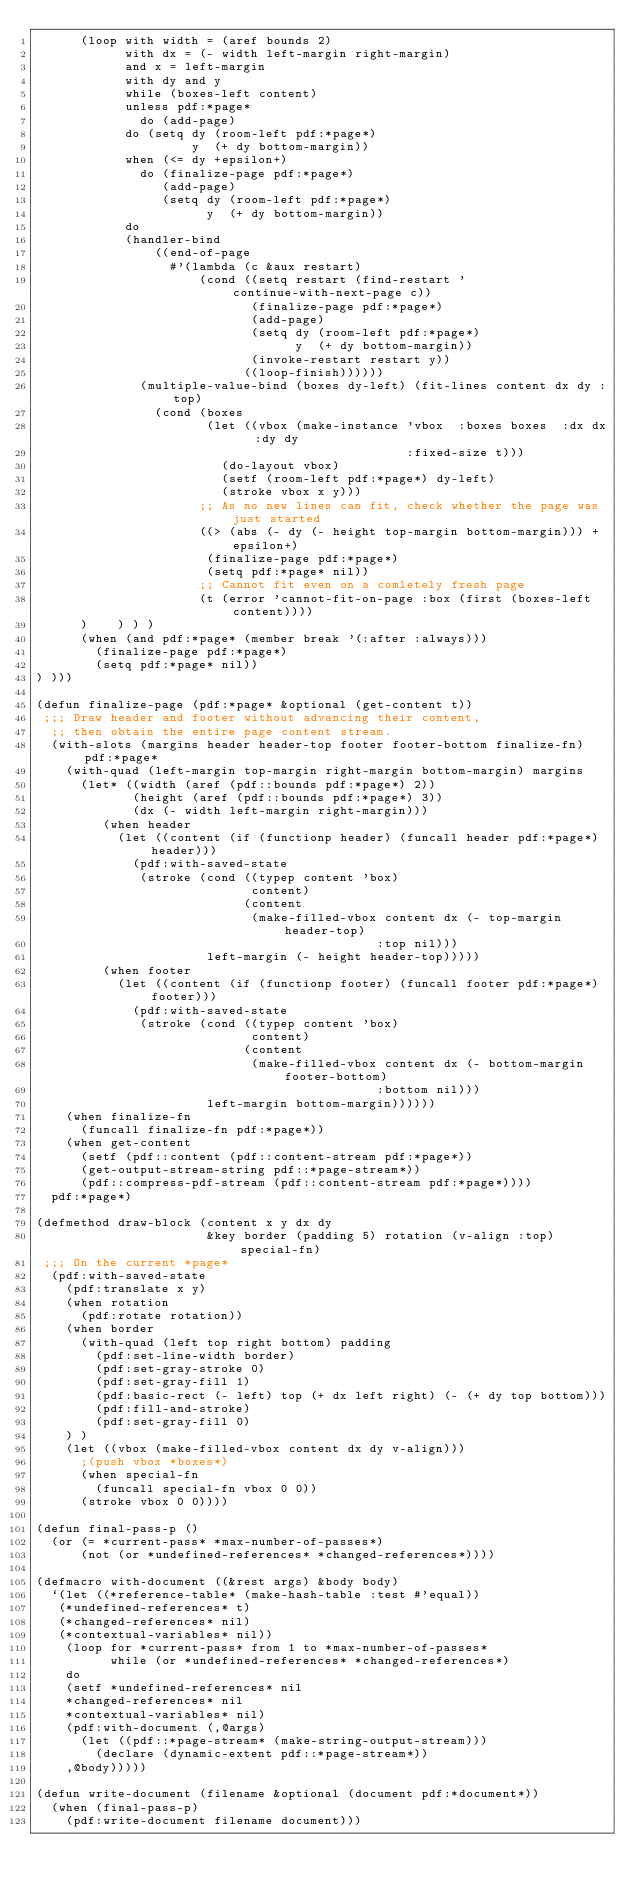<code> <loc_0><loc_0><loc_500><loc_500><_Lisp_>      (loop with width = (aref bounds 2)
            with dx = (- width left-margin right-margin)
            and x = left-margin
            with dy and y
            while (boxes-left content)
            unless pdf:*page* 
              do (add-page)
            do (setq dy (room-left pdf:*page*)
                     y  (+ dy bottom-margin))
            when (<= dy +epsilon+)
              do (finalize-page pdf:*page*)
                 (add-page)
                 (setq dy (room-left pdf:*page*)
                       y  (+ dy bottom-margin))
            do
            (handler-bind
                ((end-of-page
                  #'(lambda (c &aux restart)
                      (cond ((setq restart (find-restart 'continue-with-next-page c))
                             (finalize-page pdf:*page*)
                             (add-page)
                             (setq dy (room-left pdf:*page*)
                                   y  (+ dy bottom-margin))
                             (invoke-restart restart y))
                            ((loop-finish))))))
              (multiple-value-bind (boxes dy-left) (fit-lines content dx dy :top)
                (cond (boxes
                       (let ((vbox (make-instance 'vbox  :boxes boxes  :dx dx  :dy dy 
                                                  :fixed-size t)))
                         (do-layout vbox)
                         (setf (room-left pdf:*page*) dy-left)
                         (stroke vbox x y)))
                      ;; As no new lines can fit, check whether the page was just started
                      ((> (abs (- dy (- height top-margin bottom-margin))) +epsilon+)
                       (finalize-page pdf:*page*)
                       (setq pdf:*page* nil))
                      ;; Cannot fit even on a comletely fresh page
                      (t (error 'cannot-fit-on-page :box (first (boxes-left content))))
      )    ) ) )
      (when (and pdf:*page* (member break '(:after :always)))
        (finalize-page pdf:*page*)
        (setq pdf:*page* nil))
) )))

(defun finalize-page (pdf:*page* &optional (get-content t))
 ;;; Draw header and footer without advancing their content,
  ;; then obtain the entire page content stream.
  (with-slots (margins header header-top footer footer-bottom finalize-fn) pdf:*page*
    (with-quad (left-margin top-margin right-margin bottom-margin) margins
      (let* ((width (aref (pdf::bounds pdf:*page*) 2))
             (height (aref (pdf::bounds pdf:*page*) 3))
             (dx (- width left-margin right-margin)))
         (when header
           (let ((content (if (functionp header) (funcall header pdf:*page*) header)))
             (pdf:with-saved-state
              (stroke (cond ((typep content 'box)
                             content)
                            (content
                             (make-filled-vbox content dx (- top-margin header-top)
                                              :top nil)))
                       left-margin (- height header-top)))))
         (when footer
           (let ((content (if (functionp footer) (funcall footer pdf:*page*) footer)))
             (pdf:with-saved-state
              (stroke (cond ((typep content 'box)
                             content)
                            (content
                             (make-filled-vbox content dx (- bottom-margin footer-bottom)
                                              :bottom nil)))
                       left-margin bottom-margin))))))
    (when finalize-fn
      (funcall finalize-fn pdf:*page*))
    (when get-content
      (setf (pdf::content (pdf::content-stream pdf:*page*))
	    (get-output-stream-string pdf::*page-stream*))
      (pdf::compress-pdf-stream (pdf::content-stream pdf:*page*))))
  pdf:*page*)

(defmethod draw-block (content x y dx dy 
                       &key border (padding 5) rotation (v-align :top) special-fn)
 ;;; On the current *page*
  (pdf:with-saved-state
    (pdf:translate x y)
    (when rotation
      (pdf:rotate rotation))
    (when border
      (with-quad (left top right bottom) padding
        (pdf:set-line-width border)
        (pdf:set-gray-stroke 0)
        (pdf:set-gray-fill 1)
        (pdf:basic-rect (- left) top (+ dx left right) (- (+ dy top bottom)))
        (pdf:fill-and-stroke)
        (pdf:set-gray-fill 0)
    ) )
    (let ((vbox (make-filled-vbox content dx dy v-align)))
      ;(push vbox *boxes*)
      (when special-fn
        (funcall special-fn vbox 0 0))
      (stroke vbox 0 0))))

(defun final-pass-p ()
  (or (= *current-pass* *max-number-of-passes*)
      (not (or *undefined-references* *changed-references*))))

(defmacro with-document ((&rest args) &body body)
  `(let ((*reference-table* (make-hash-table :test #'equal))
	 (*undefined-references* t)
	 (*changed-references* nil)
	 (*contextual-variables* nil))
    (loop for *current-pass* from 1 to *max-number-of-passes*
          while (or *undefined-references* *changed-references*)
	  do
	  (setf *undefined-references* nil
		*changed-references* nil
		*contextual-variables* nil)
	  (pdf:with-document (,@args)
	    (let ((pdf::*page-stream* (make-string-output-stream)))
	      (declare (dynamic-extent pdf::*page-stream*))
		,@body)))))

(defun write-document (filename &optional (document pdf:*document*))
  (when (final-pass-p)
    (pdf:write-document filename document)))

</code> 